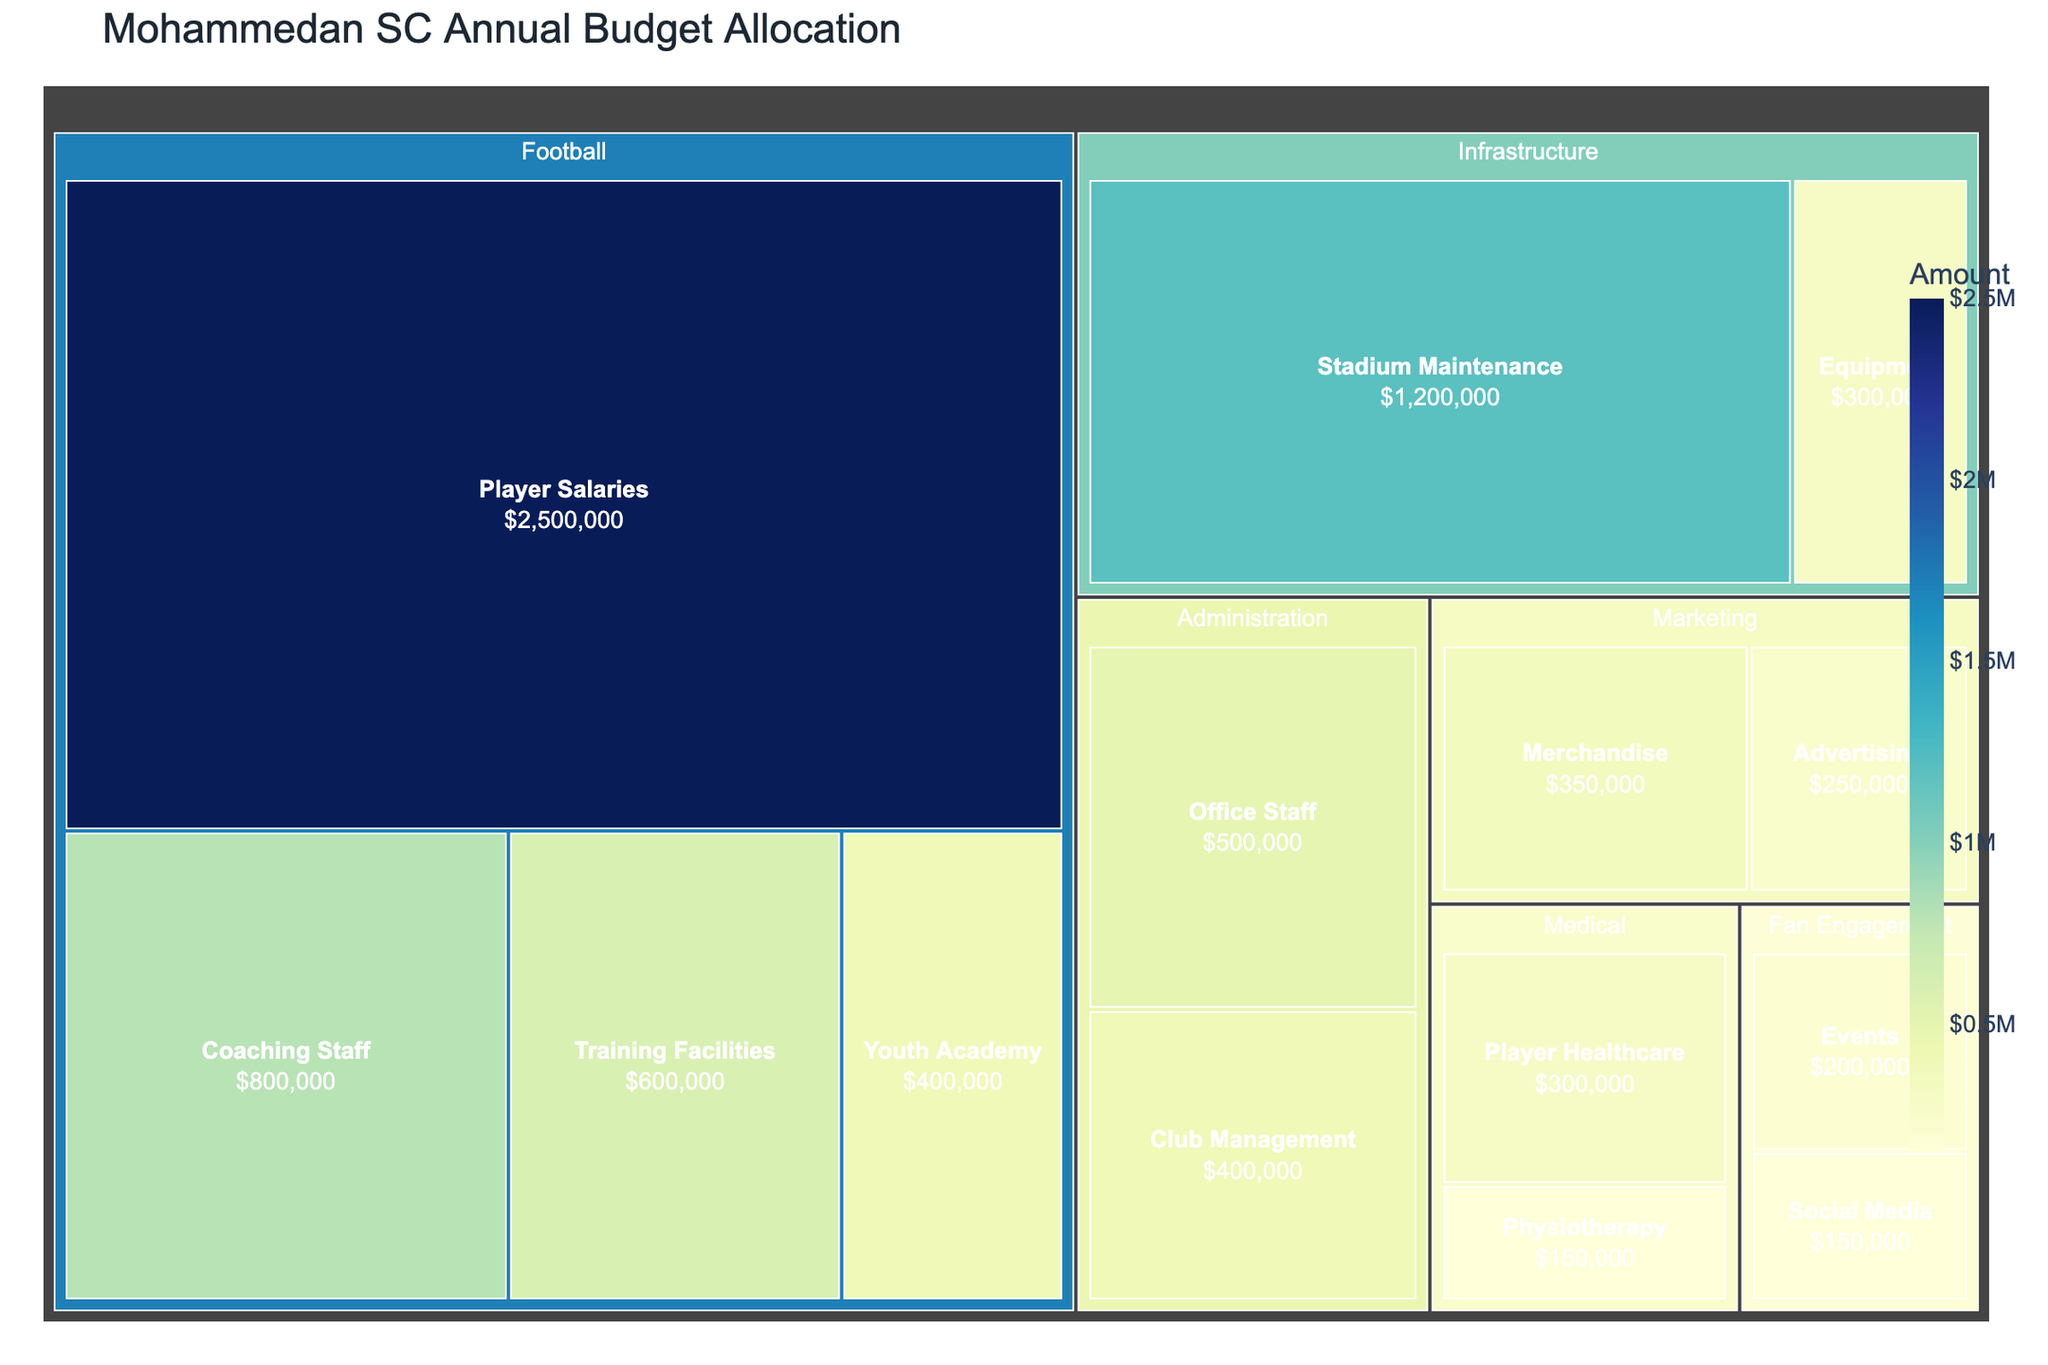What's the total budget allocated to the Football department? To find the total budget for the Football department, sum up the amounts allocated to each category within it: Player Salaries ($2500000), Coaching Staff ($800000), Training Facilities ($600000), and Youth Academy ($400000). So, $2500000 + $800000 + $600000 + $400000 = $4300000
Answer: $4300000 Which category has the highest allocation in the Infrastructure department? Look at the categories under the Infrastructure department and compare their amounts. Stadium Maintenance has $1200000 and Equipment has $300000. Stadium Maintenance has the highest allocation.
Answer: Stadium Maintenance How much more is allocated to Player Salaries than Club Management? Find the allocation for Player Salaries ($2500000) and Club Management ($400000). Subtract the smaller amount from the larger amount: $2500000 - $400000 = $2100000
Answer: $2100000 Which department has the smallest total allocation and how much is it? Sum the allocations for each department and compare. Medical: Player Healthcare ($300000) + Physiotherapy ($150000) = $450000. Compare this sum to other departments' totals to conclude that Medical has the smallest total allocation.
Answer: Medical, $450000 What is the total budget for Fan Engagement? Add the amounts allocated to Events ($200000) and Social Media ($150000). So, $200000 + $150000 = $350000
Answer: $350000 Which category in Marketing has a larger allocation, and what is the difference between the two? Compare Merchandise ($350000) and Advertising ($250000). Merchandise has a larger allocation. The difference is $350000 - $250000 = $100000
Answer: Merchandise, $100000 Is the total amount allocated to Administration more or less than that allocated to Marketing and by how much? Sum the Administration categories: Office Staff ($500000) + Club Management ($400000) = $900000. Sum the Marketing categories: Merchandise ($350000) + Advertising ($250000) = $600000. The difference is $900000 - $600000 = $300000
Answer: More, $300000 What's the combined budget for Player Salaries and Stadium Maintenance? Add the amounts for Player Salaries ($2500000) and Stadium Maintenance ($1200000). So, $2500000 + $1200000 = $3700000
Answer: $3700000 